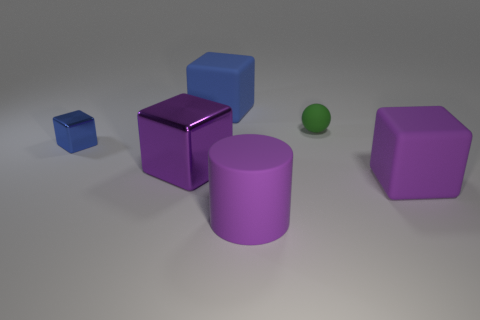There is a thing behind the green rubber object; what is its color?
Provide a short and direct response. Blue. Is the small sphere made of the same material as the large purple cube that is in front of the large purple metallic thing?
Provide a succinct answer. Yes. What is the material of the big blue cube?
Your answer should be compact. Rubber. What is the shape of the small green object that is made of the same material as the cylinder?
Offer a terse response. Sphere. How many other things are the same shape as the purple metallic thing?
Keep it short and to the point. 3. How many cylinders are behind the big matte cylinder?
Ensure brevity in your answer.  0. Is the size of the green rubber ball that is behind the tiny blue thing the same as the blue metal object that is left of the purple matte cylinder?
Offer a very short reply. Yes. What number of other things are there of the same size as the purple metallic thing?
Offer a terse response. 3. There is a block that is on the right side of the green rubber ball that is behind the blue block that is in front of the tiny green matte ball; what is it made of?
Your response must be concise. Rubber. There is a purple rubber cylinder; is it the same size as the blue metal cube that is left of the purple metal object?
Your response must be concise. No. 